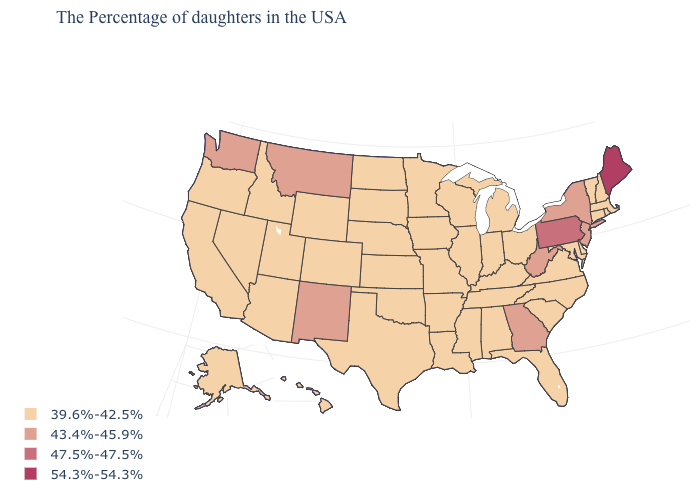Among the states that border Massachusetts , does New York have the highest value?
Write a very short answer. Yes. What is the value of Utah?
Quick response, please. 39.6%-42.5%. Does Iowa have the same value as Connecticut?
Short answer required. Yes. Name the states that have a value in the range 39.6%-42.5%?
Answer briefly. Massachusetts, Rhode Island, New Hampshire, Vermont, Connecticut, Delaware, Maryland, Virginia, North Carolina, South Carolina, Ohio, Florida, Michigan, Kentucky, Indiana, Alabama, Tennessee, Wisconsin, Illinois, Mississippi, Louisiana, Missouri, Arkansas, Minnesota, Iowa, Kansas, Nebraska, Oklahoma, Texas, South Dakota, North Dakota, Wyoming, Colorado, Utah, Arizona, Idaho, Nevada, California, Oregon, Alaska, Hawaii. Does Georgia have the lowest value in the USA?
Answer briefly. No. How many symbols are there in the legend?
Write a very short answer. 4. Which states have the lowest value in the USA?
Short answer required. Massachusetts, Rhode Island, New Hampshire, Vermont, Connecticut, Delaware, Maryland, Virginia, North Carolina, South Carolina, Ohio, Florida, Michigan, Kentucky, Indiana, Alabama, Tennessee, Wisconsin, Illinois, Mississippi, Louisiana, Missouri, Arkansas, Minnesota, Iowa, Kansas, Nebraska, Oklahoma, Texas, South Dakota, North Dakota, Wyoming, Colorado, Utah, Arizona, Idaho, Nevada, California, Oregon, Alaska, Hawaii. What is the value of Alabama?
Keep it brief. 39.6%-42.5%. What is the highest value in the MidWest ?
Short answer required. 39.6%-42.5%. What is the value of Colorado?
Keep it brief. 39.6%-42.5%. What is the lowest value in the USA?
Short answer required. 39.6%-42.5%. Name the states that have a value in the range 43.4%-45.9%?
Give a very brief answer. New York, New Jersey, West Virginia, Georgia, New Mexico, Montana, Washington. Which states hav the highest value in the MidWest?
Short answer required. Ohio, Michigan, Indiana, Wisconsin, Illinois, Missouri, Minnesota, Iowa, Kansas, Nebraska, South Dakota, North Dakota. What is the lowest value in states that border Florida?
Give a very brief answer. 39.6%-42.5%. Among the states that border New Mexico , which have the highest value?
Short answer required. Oklahoma, Texas, Colorado, Utah, Arizona. 